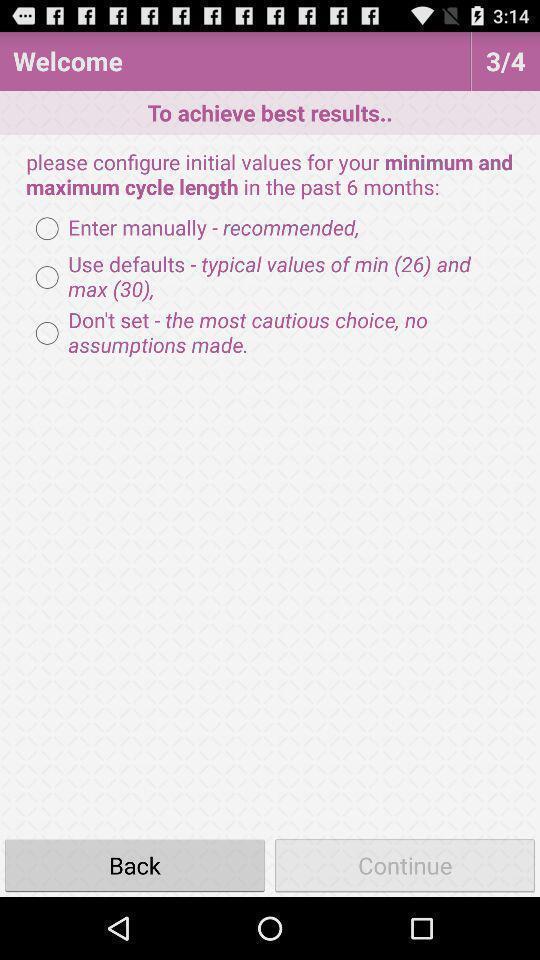Describe the key features of this screenshot. Welcome page with list of instructions. 